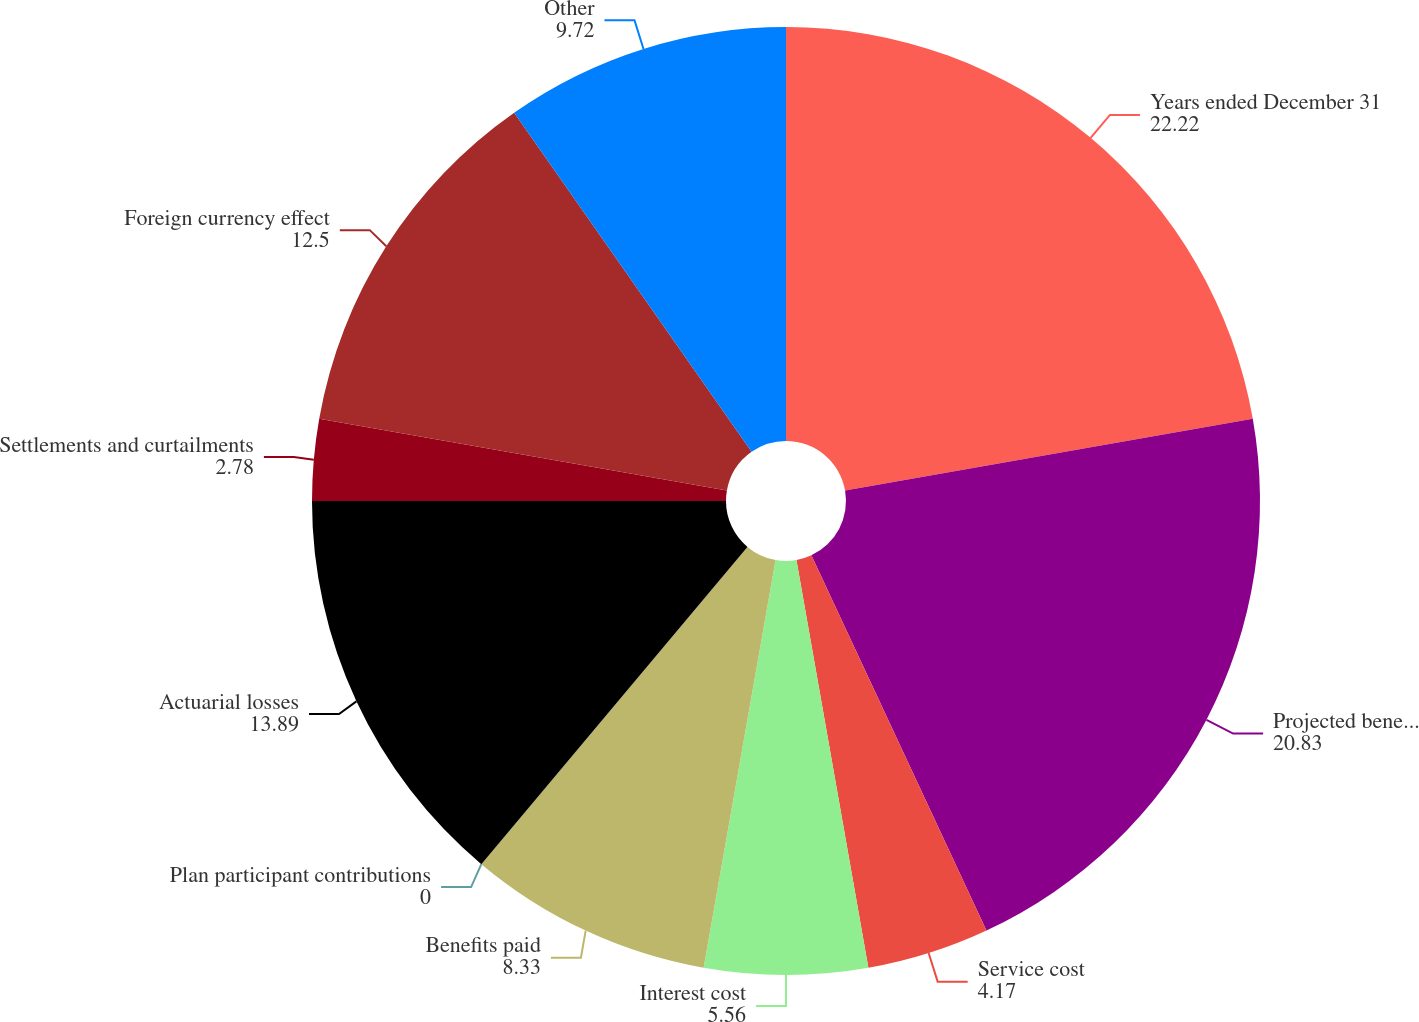Convert chart to OTSL. <chart><loc_0><loc_0><loc_500><loc_500><pie_chart><fcel>Years ended December 31<fcel>Projected benefit obligation<fcel>Service cost<fcel>Interest cost<fcel>Benefits paid<fcel>Plan participant contributions<fcel>Actuarial losses<fcel>Settlements and curtailments<fcel>Foreign currency effect<fcel>Other<nl><fcel>22.22%<fcel>20.83%<fcel>4.17%<fcel>5.56%<fcel>8.33%<fcel>0.0%<fcel>13.89%<fcel>2.78%<fcel>12.5%<fcel>9.72%<nl></chart> 